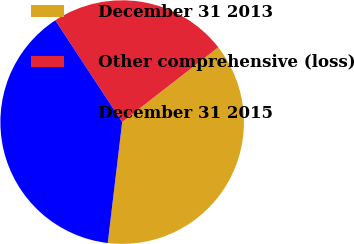Convert chart to OTSL. <chart><loc_0><loc_0><loc_500><loc_500><pie_chart><fcel>December 31 2013<fcel>Other comprehensive (loss)<fcel>December 31 2015<nl><fcel>37.42%<fcel>23.72%<fcel>38.86%<nl></chart> 